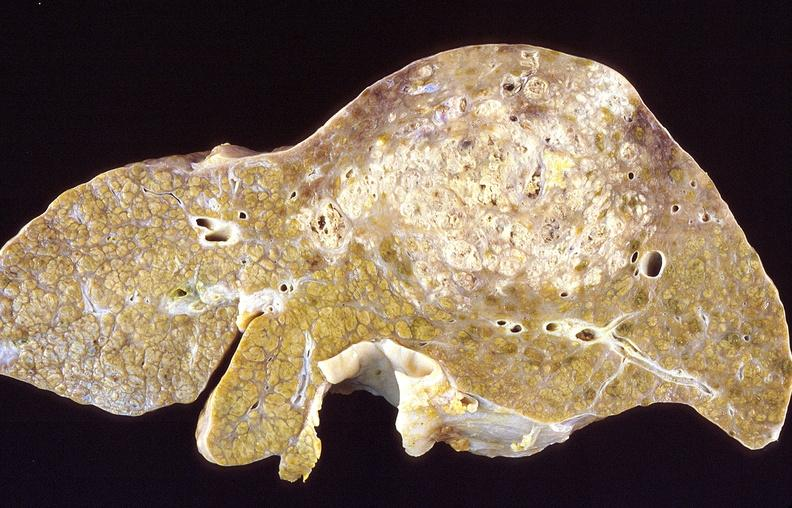does this image show hepatocellular carcinoma, hepatitis c positive?
Answer the question using a single word or phrase. Yes 